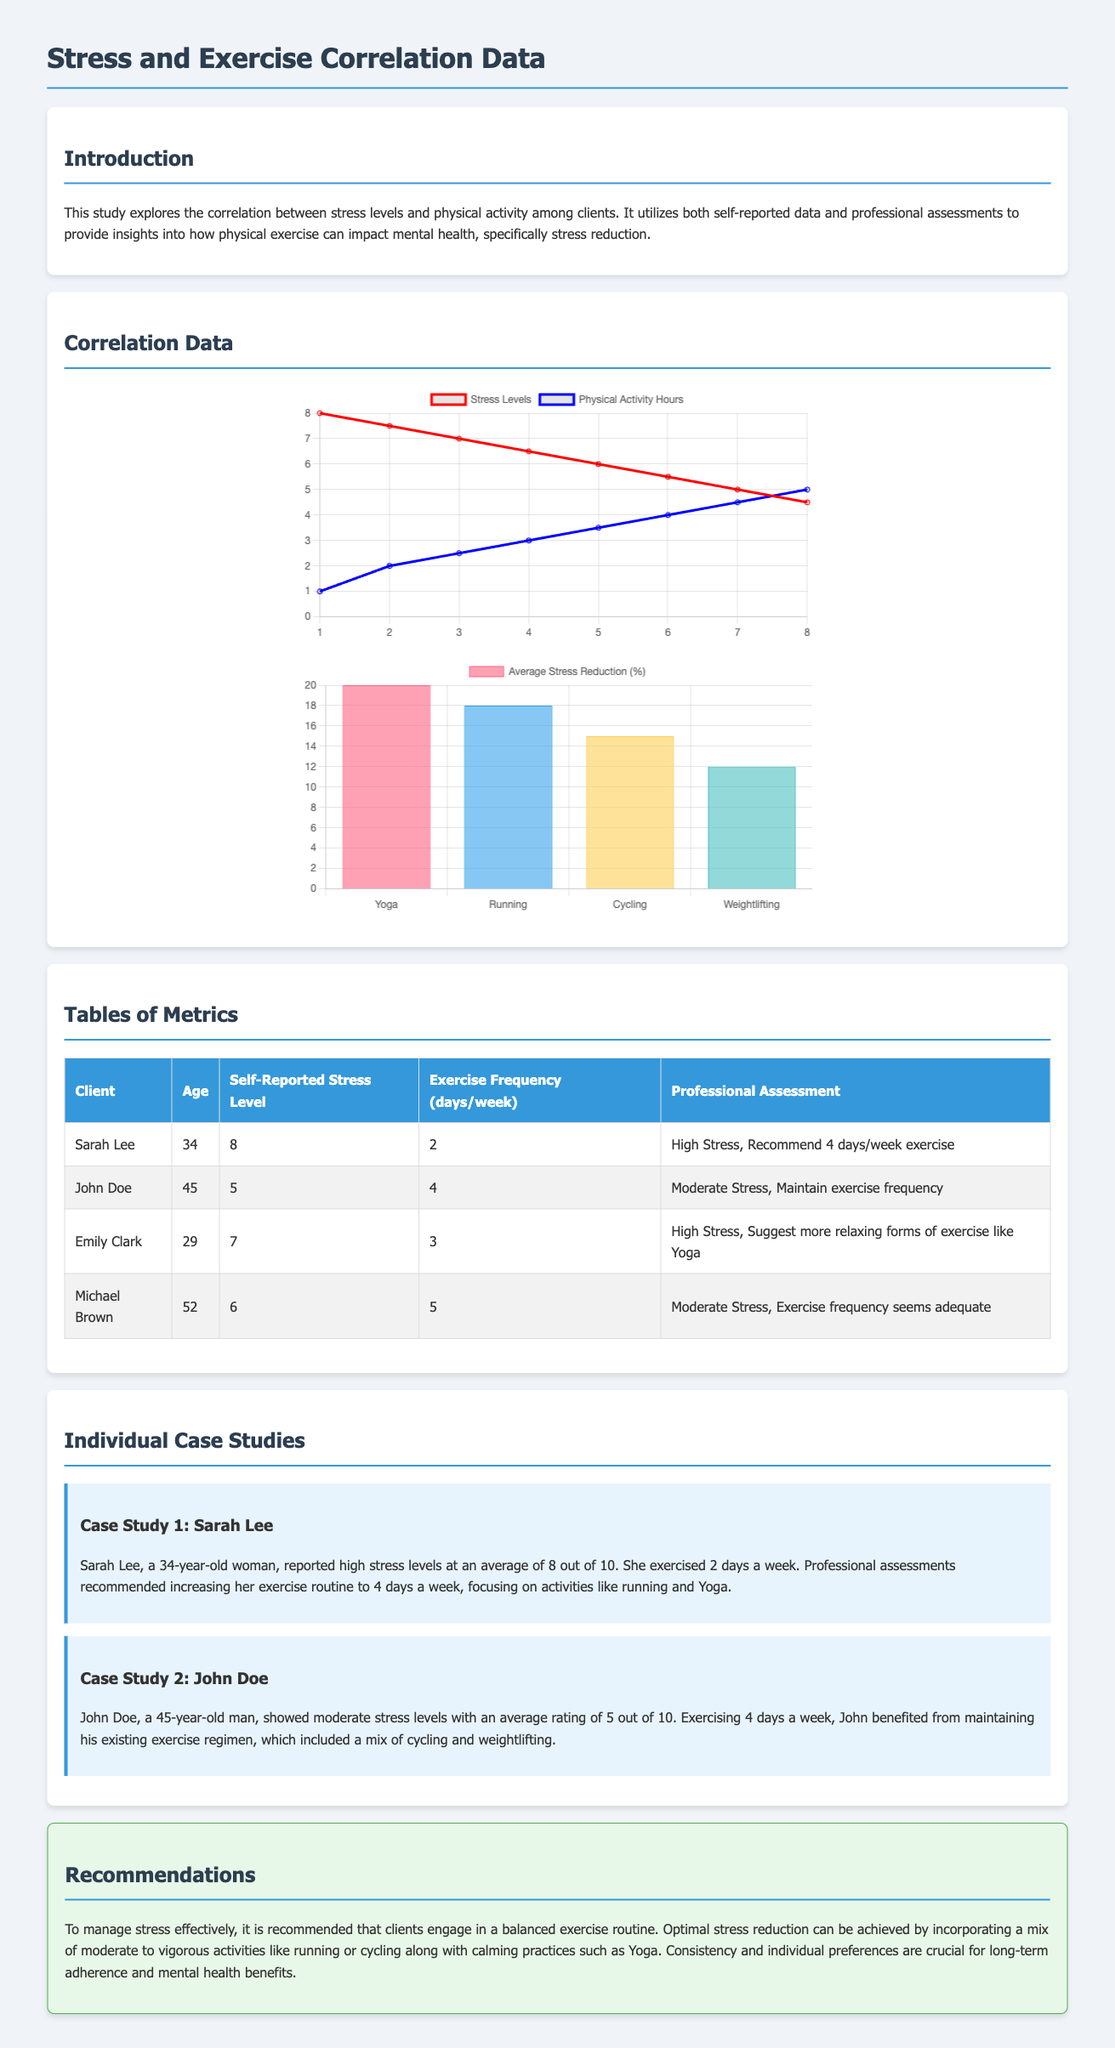What is the average self-reported stress level for Sarah Lee? Sarah Lee's self-reported stress level is listed in the table as 8 out of 10.
Answer: 8 How many days a week does John Doe exercise? The table indicates that John Doe exercises 4 days a week.
Answer: 4 What type of exercise is suggested for Emily Clark? The professional assessment for Emily Clark suggests more relaxing forms of exercise like Yoga.
Answer: Yoga What was the average stress reduction percentage for Running? The stress reduction chart shows that Running leads to an average stress reduction of 18%.
Answer: 18% What is the relation between physical activity hours and stress levels according to the chart? The chart implies that as physical activity hours increase, stress levels decrease.
Answer: decrease 